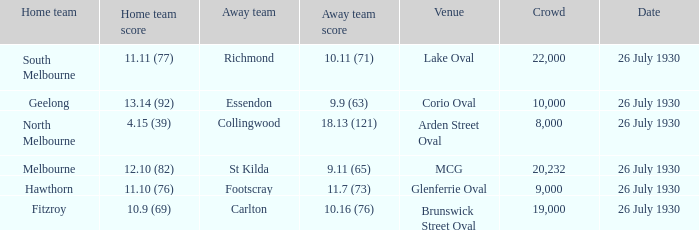Where did Geelong play a home game? Corio Oval. 